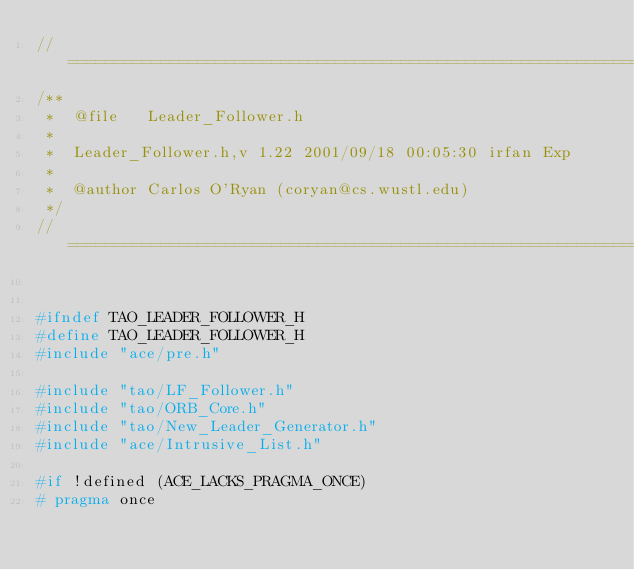<code> <loc_0><loc_0><loc_500><loc_500><_C_>//=============================================================================
/**
 *  @file   Leader_Follower.h
 *
 *  Leader_Follower.h,v 1.22 2001/09/18 00:05:30 irfan Exp
 *
 *  @author Carlos O'Ryan (coryan@cs.wustl.edu)
 */
//=============================================================================


#ifndef TAO_LEADER_FOLLOWER_H
#define TAO_LEADER_FOLLOWER_H
#include "ace/pre.h"

#include "tao/LF_Follower.h"
#include "tao/ORB_Core.h"
#include "tao/New_Leader_Generator.h"
#include "ace/Intrusive_List.h"

#if !defined (ACE_LACKS_PRAGMA_ONCE)
# pragma once</code> 